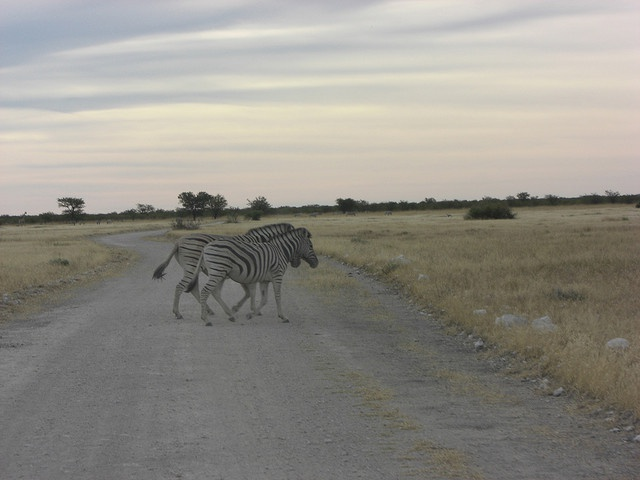Describe the objects in this image and their specific colors. I can see zebra in lightgray, gray, and black tones and zebra in lightgray, gray, and black tones in this image. 